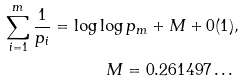Convert formula to latex. <formula><loc_0><loc_0><loc_500><loc_500>\sum _ { i = 1 } ^ { m } \frac { 1 } { p _ { i } } = \log \log p _ { m } + M + 0 ( 1 ) , \\ M = 0 . 2 6 1 4 9 7 \dots \</formula> 